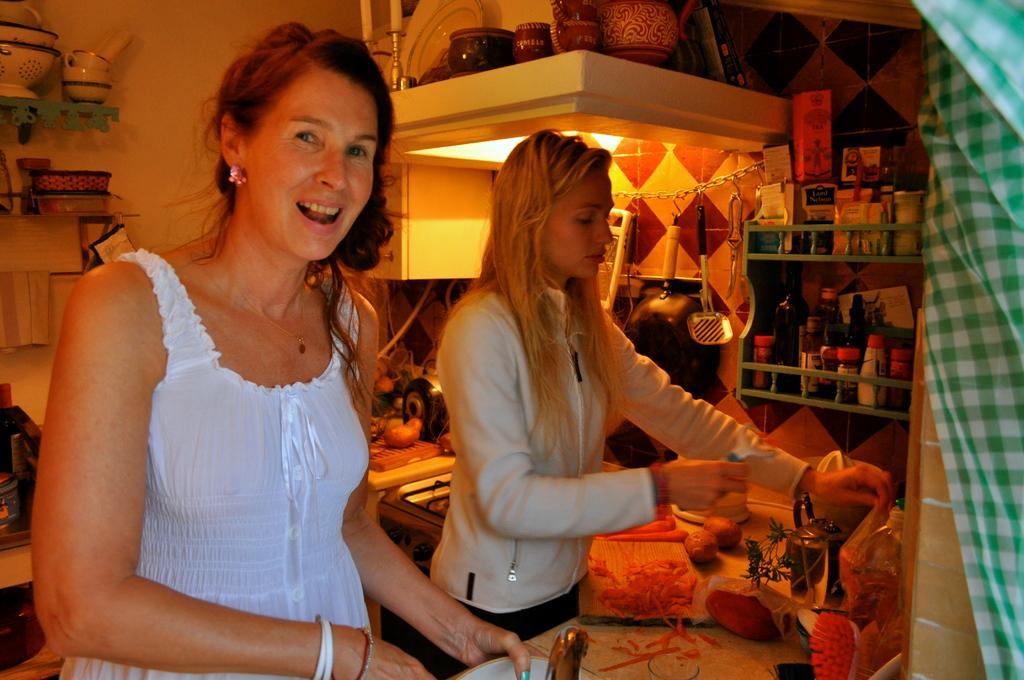In one or two sentences, can you explain what this image depicts? In this picture there is a woman with white dress is standing and holding the object and she might be talking and there is a woman standing and holding the object. There are bottles in the shelf and there are objects and there is a stove on the table. There are ceramic objects in shelf. On the right side of the image there is a cloth. At the back there's a light. 